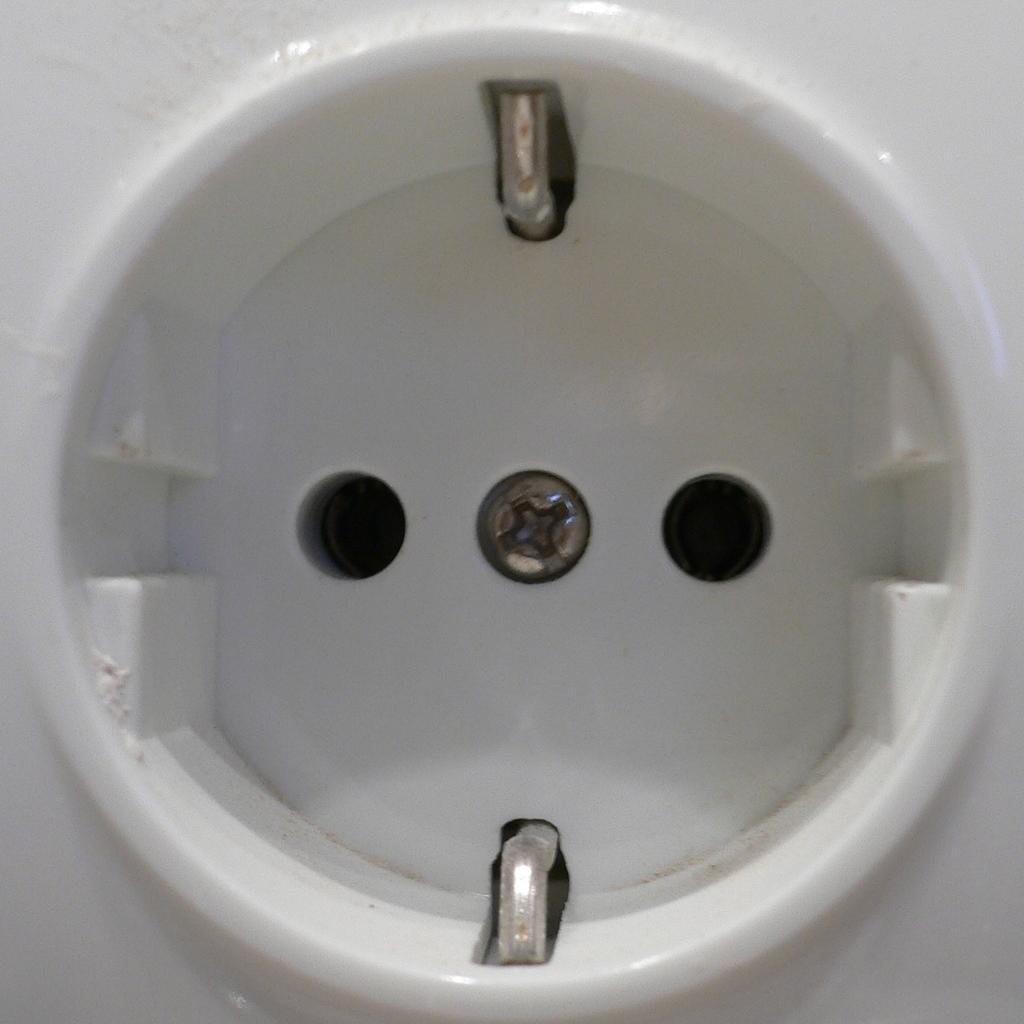What can be seen in the image related to electricity? There is a socket in the image. What type of bucket is being played by the guitarist in the image? There is no guitarist or bucket present in the image; it only features a socket. 